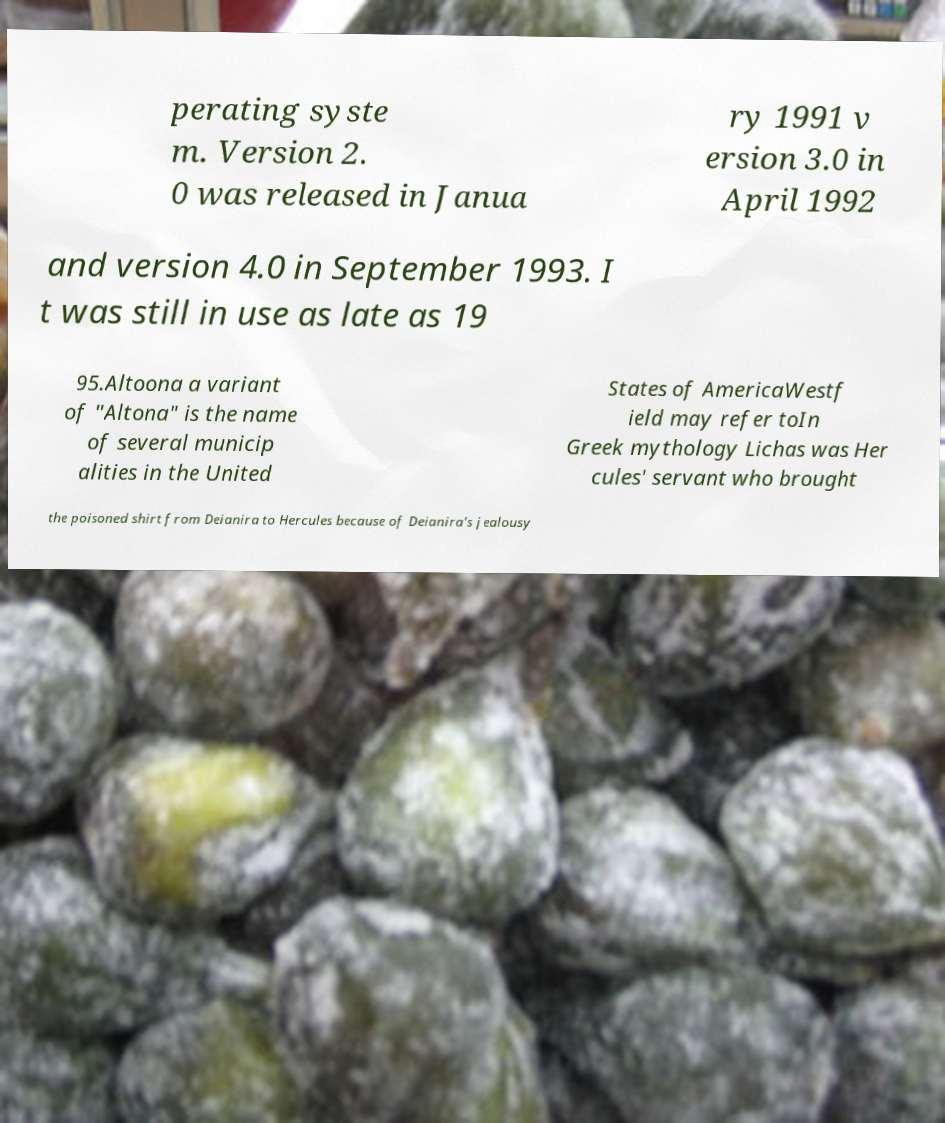For documentation purposes, I need the text within this image transcribed. Could you provide that? perating syste m. Version 2. 0 was released in Janua ry 1991 v ersion 3.0 in April 1992 and version 4.0 in September 1993. I t was still in use as late as 19 95.Altoona a variant of "Altona" is the name of several municip alities in the United States of AmericaWestf ield may refer toIn Greek mythology Lichas was Her cules' servant who brought the poisoned shirt from Deianira to Hercules because of Deianira's jealousy 